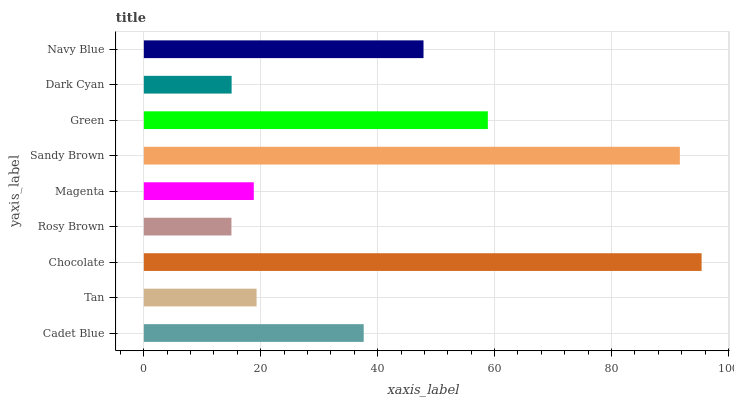Is Rosy Brown the minimum?
Answer yes or no. Yes. Is Chocolate the maximum?
Answer yes or no. Yes. Is Tan the minimum?
Answer yes or no. No. Is Tan the maximum?
Answer yes or no. No. Is Cadet Blue greater than Tan?
Answer yes or no. Yes. Is Tan less than Cadet Blue?
Answer yes or no. Yes. Is Tan greater than Cadet Blue?
Answer yes or no. No. Is Cadet Blue less than Tan?
Answer yes or no. No. Is Cadet Blue the high median?
Answer yes or no. Yes. Is Cadet Blue the low median?
Answer yes or no. Yes. Is Chocolate the high median?
Answer yes or no. No. Is Chocolate the low median?
Answer yes or no. No. 